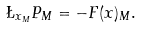<formula> <loc_0><loc_0><loc_500><loc_500>\L _ { x _ { M } } P _ { M } = - F ( x ) _ { M } .</formula> 